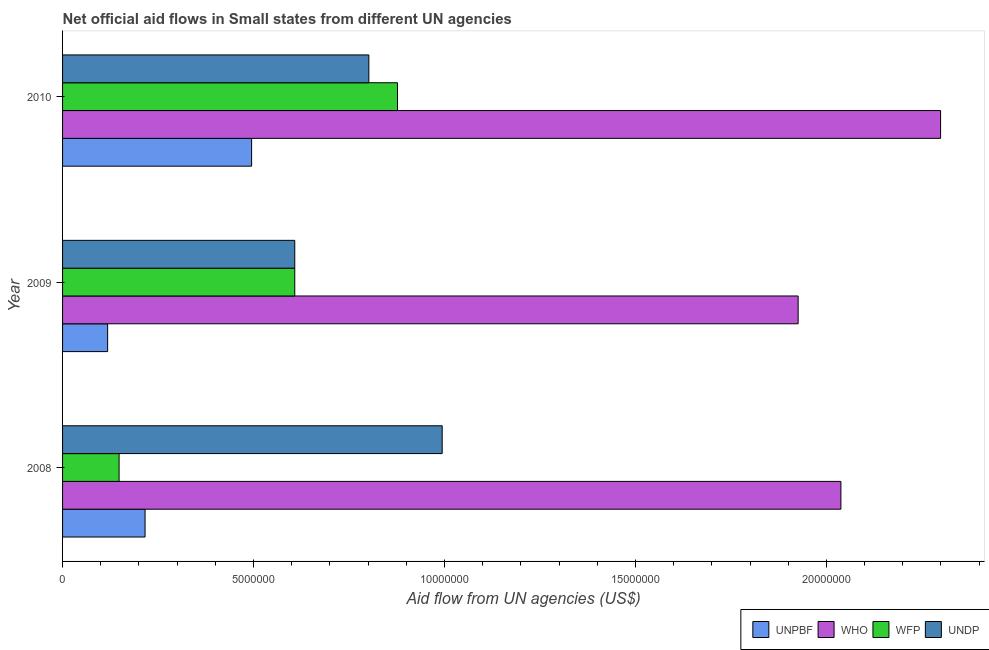How many different coloured bars are there?
Provide a succinct answer. 4. Are the number of bars per tick equal to the number of legend labels?
Your answer should be very brief. Yes. How many bars are there on the 1st tick from the bottom?
Ensure brevity in your answer.  4. What is the label of the 3rd group of bars from the top?
Provide a short and direct response. 2008. What is the amount of aid given by who in 2010?
Your answer should be very brief. 2.30e+07. Across all years, what is the maximum amount of aid given by wfp?
Your answer should be very brief. 8.77e+06. Across all years, what is the minimum amount of aid given by wfp?
Your answer should be very brief. 1.48e+06. In which year was the amount of aid given by wfp minimum?
Offer a terse response. 2008. What is the total amount of aid given by who in the graph?
Provide a succinct answer. 6.26e+07. What is the difference between the amount of aid given by undp in 2008 and that in 2010?
Offer a very short reply. 1.92e+06. What is the difference between the amount of aid given by unpbf in 2009 and the amount of aid given by wfp in 2008?
Provide a short and direct response. -3.00e+05. What is the average amount of aid given by who per year?
Keep it short and to the point. 2.09e+07. In the year 2010, what is the difference between the amount of aid given by wfp and amount of aid given by undp?
Make the answer very short. 7.50e+05. In how many years, is the amount of aid given by unpbf greater than 12000000 US$?
Your answer should be compact. 0. What is the ratio of the amount of aid given by unpbf in 2008 to that in 2010?
Provide a succinct answer. 0.44. Is the amount of aid given by unpbf in 2008 less than that in 2010?
Offer a very short reply. Yes. What is the difference between the highest and the second highest amount of aid given by wfp?
Ensure brevity in your answer.  2.69e+06. What is the difference between the highest and the lowest amount of aid given by undp?
Your response must be concise. 3.86e+06. In how many years, is the amount of aid given by unpbf greater than the average amount of aid given by unpbf taken over all years?
Offer a very short reply. 1. Is the sum of the amount of aid given by undp in 2008 and 2010 greater than the maximum amount of aid given by wfp across all years?
Offer a very short reply. Yes. Is it the case that in every year, the sum of the amount of aid given by unpbf and amount of aid given by wfp is greater than the sum of amount of aid given by who and amount of aid given by undp?
Offer a terse response. Yes. What does the 2nd bar from the top in 2010 represents?
Your response must be concise. WFP. What does the 3rd bar from the bottom in 2010 represents?
Your response must be concise. WFP. Is it the case that in every year, the sum of the amount of aid given by unpbf and amount of aid given by who is greater than the amount of aid given by wfp?
Offer a terse response. Yes. Are all the bars in the graph horizontal?
Your response must be concise. Yes. How many years are there in the graph?
Ensure brevity in your answer.  3. Does the graph contain any zero values?
Provide a short and direct response. No. Does the graph contain grids?
Ensure brevity in your answer.  No. Where does the legend appear in the graph?
Provide a succinct answer. Bottom right. How many legend labels are there?
Provide a succinct answer. 4. What is the title of the graph?
Offer a very short reply. Net official aid flows in Small states from different UN agencies. What is the label or title of the X-axis?
Provide a succinct answer. Aid flow from UN agencies (US$). What is the Aid flow from UN agencies (US$) in UNPBF in 2008?
Make the answer very short. 2.16e+06. What is the Aid flow from UN agencies (US$) of WHO in 2008?
Provide a succinct answer. 2.04e+07. What is the Aid flow from UN agencies (US$) in WFP in 2008?
Your response must be concise. 1.48e+06. What is the Aid flow from UN agencies (US$) in UNDP in 2008?
Give a very brief answer. 9.94e+06. What is the Aid flow from UN agencies (US$) of UNPBF in 2009?
Offer a terse response. 1.18e+06. What is the Aid flow from UN agencies (US$) of WHO in 2009?
Keep it short and to the point. 1.93e+07. What is the Aid flow from UN agencies (US$) in WFP in 2009?
Your answer should be compact. 6.08e+06. What is the Aid flow from UN agencies (US$) of UNDP in 2009?
Give a very brief answer. 6.08e+06. What is the Aid flow from UN agencies (US$) in UNPBF in 2010?
Make the answer very short. 4.95e+06. What is the Aid flow from UN agencies (US$) of WHO in 2010?
Your answer should be compact. 2.30e+07. What is the Aid flow from UN agencies (US$) in WFP in 2010?
Make the answer very short. 8.77e+06. What is the Aid flow from UN agencies (US$) in UNDP in 2010?
Your answer should be compact. 8.02e+06. Across all years, what is the maximum Aid flow from UN agencies (US$) in UNPBF?
Keep it short and to the point. 4.95e+06. Across all years, what is the maximum Aid flow from UN agencies (US$) of WHO?
Offer a terse response. 2.30e+07. Across all years, what is the maximum Aid flow from UN agencies (US$) of WFP?
Make the answer very short. 8.77e+06. Across all years, what is the maximum Aid flow from UN agencies (US$) of UNDP?
Offer a very short reply. 9.94e+06. Across all years, what is the minimum Aid flow from UN agencies (US$) in UNPBF?
Make the answer very short. 1.18e+06. Across all years, what is the minimum Aid flow from UN agencies (US$) of WHO?
Ensure brevity in your answer.  1.93e+07. Across all years, what is the minimum Aid flow from UN agencies (US$) in WFP?
Ensure brevity in your answer.  1.48e+06. Across all years, what is the minimum Aid flow from UN agencies (US$) in UNDP?
Provide a succinct answer. 6.08e+06. What is the total Aid flow from UN agencies (US$) in UNPBF in the graph?
Give a very brief answer. 8.29e+06. What is the total Aid flow from UN agencies (US$) of WHO in the graph?
Your answer should be very brief. 6.26e+07. What is the total Aid flow from UN agencies (US$) in WFP in the graph?
Your response must be concise. 1.63e+07. What is the total Aid flow from UN agencies (US$) of UNDP in the graph?
Provide a short and direct response. 2.40e+07. What is the difference between the Aid flow from UN agencies (US$) in UNPBF in 2008 and that in 2009?
Your answer should be very brief. 9.80e+05. What is the difference between the Aid flow from UN agencies (US$) of WHO in 2008 and that in 2009?
Your answer should be compact. 1.12e+06. What is the difference between the Aid flow from UN agencies (US$) in WFP in 2008 and that in 2009?
Make the answer very short. -4.60e+06. What is the difference between the Aid flow from UN agencies (US$) in UNDP in 2008 and that in 2009?
Provide a short and direct response. 3.86e+06. What is the difference between the Aid flow from UN agencies (US$) of UNPBF in 2008 and that in 2010?
Give a very brief answer. -2.79e+06. What is the difference between the Aid flow from UN agencies (US$) in WHO in 2008 and that in 2010?
Ensure brevity in your answer.  -2.61e+06. What is the difference between the Aid flow from UN agencies (US$) in WFP in 2008 and that in 2010?
Provide a succinct answer. -7.29e+06. What is the difference between the Aid flow from UN agencies (US$) of UNDP in 2008 and that in 2010?
Make the answer very short. 1.92e+06. What is the difference between the Aid flow from UN agencies (US$) of UNPBF in 2009 and that in 2010?
Your response must be concise. -3.77e+06. What is the difference between the Aid flow from UN agencies (US$) of WHO in 2009 and that in 2010?
Provide a short and direct response. -3.73e+06. What is the difference between the Aid flow from UN agencies (US$) in WFP in 2009 and that in 2010?
Keep it short and to the point. -2.69e+06. What is the difference between the Aid flow from UN agencies (US$) of UNDP in 2009 and that in 2010?
Offer a very short reply. -1.94e+06. What is the difference between the Aid flow from UN agencies (US$) in UNPBF in 2008 and the Aid flow from UN agencies (US$) in WHO in 2009?
Ensure brevity in your answer.  -1.71e+07. What is the difference between the Aid flow from UN agencies (US$) of UNPBF in 2008 and the Aid flow from UN agencies (US$) of WFP in 2009?
Offer a terse response. -3.92e+06. What is the difference between the Aid flow from UN agencies (US$) in UNPBF in 2008 and the Aid flow from UN agencies (US$) in UNDP in 2009?
Ensure brevity in your answer.  -3.92e+06. What is the difference between the Aid flow from UN agencies (US$) in WHO in 2008 and the Aid flow from UN agencies (US$) in WFP in 2009?
Offer a very short reply. 1.43e+07. What is the difference between the Aid flow from UN agencies (US$) in WHO in 2008 and the Aid flow from UN agencies (US$) in UNDP in 2009?
Give a very brief answer. 1.43e+07. What is the difference between the Aid flow from UN agencies (US$) in WFP in 2008 and the Aid flow from UN agencies (US$) in UNDP in 2009?
Provide a short and direct response. -4.60e+06. What is the difference between the Aid flow from UN agencies (US$) of UNPBF in 2008 and the Aid flow from UN agencies (US$) of WHO in 2010?
Offer a terse response. -2.08e+07. What is the difference between the Aid flow from UN agencies (US$) of UNPBF in 2008 and the Aid flow from UN agencies (US$) of WFP in 2010?
Keep it short and to the point. -6.61e+06. What is the difference between the Aid flow from UN agencies (US$) of UNPBF in 2008 and the Aid flow from UN agencies (US$) of UNDP in 2010?
Offer a very short reply. -5.86e+06. What is the difference between the Aid flow from UN agencies (US$) of WHO in 2008 and the Aid flow from UN agencies (US$) of WFP in 2010?
Keep it short and to the point. 1.16e+07. What is the difference between the Aid flow from UN agencies (US$) of WHO in 2008 and the Aid flow from UN agencies (US$) of UNDP in 2010?
Offer a very short reply. 1.24e+07. What is the difference between the Aid flow from UN agencies (US$) in WFP in 2008 and the Aid flow from UN agencies (US$) in UNDP in 2010?
Make the answer very short. -6.54e+06. What is the difference between the Aid flow from UN agencies (US$) in UNPBF in 2009 and the Aid flow from UN agencies (US$) in WHO in 2010?
Ensure brevity in your answer.  -2.18e+07. What is the difference between the Aid flow from UN agencies (US$) in UNPBF in 2009 and the Aid flow from UN agencies (US$) in WFP in 2010?
Ensure brevity in your answer.  -7.59e+06. What is the difference between the Aid flow from UN agencies (US$) of UNPBF in 2009 and the Aid flow from UN agencies (US$) of UNDP in 2010?
Make the answer very short. -6.84e+06. What is the difference between the Aid flow from UN agencies (US$) in WHO in 2009 and the Aid flow from UN agencies (US$) in WFP in 2010?
Provide a short and direct response. 1.05e+07. What is the difference between the Aid flow from UN agencies (US$) in WHO in 2009 and the Aid flow from UN agencies (US$) in UNDP in 2010?
Provide a succinct answer. 1.12e+07. What is the difference between the Aid flow from UN agencies (US$) in WFP in 2009 and the Aid flow from UN agencies (US$) in UNDP in 2010?
Give a very brief answer. -1.94e+06. What is the average Aid flow from UN agencies (US$) in UNPBF per year?
Offer a terse response. 2.76e+06. What is the average Aid flow from UN agencies (US$) of WHO per year?
Give a very brief answer. 2.09e+07. What is the average Aid flow from UN agencies (US$) in WFP per year?
Your answer should be very brief. 5.44e+06. What is the average Aid flow from UN agencies (US$) in UNDP per year?
Give a very brief answer. 8.01e+06. In the year 2008, what is the difference between the Aid flow from UN agencies (US$) of UNPBF and Aid flow from UN agencies (US$) of WHO?
Offer a very short reply. -1.82e+07. In the year 2008, what is the difference between the Aid flow from UN agencies (US$) of UNPBF and Aid flow from UN agencies (US$) of WFP?
Your response must be concise. 6.80e+05. In the year 2008, what is the difference between the Aid flow from UN agencies (US$) of UNPBF and Aid flow from UN agencies (US$) of UNDP?
Provide a short and direct response. -7.78e+06. In the year 2008, what is the difference between the Aid flow from UN agencies (US$) of WHO and Aid flow from UN agencies (US$) of WFP?
Your answer should be very brief. 1.89e+07. In the year 2008, what is the difference between the Aid flow from UN agencies (US$) in WHO and Aid flow from UN agencies (US$) in UNDP?
Your answer should be very brief. 1.04e+07. In the year 2008, what is the difference between the Aid flow from UN agencies (US$) in WFP and Aid flow from UN agencies (US$) in UNDP?
Keep it short and to the point. -8.46e+06. In the year 2009, what is the difference between the Aid flow from UN agencies (US$) of UNPBF and Aid flow from UN agencies (US$) of WHO?
Make the answer very short. -1.81e+07. In the year 2009, what is the difference between the Aid flow from UN agencies (US$) of UNPBF and Aid flow from UN agencies (US$) of WFP?
Keep it short and to the point. -4.90e+06. In the year 2009, what is the difference between the Aid flow from UN agencies (US$) of UNPBF and Aid flow from UN agencies (US$) of UNDP?
Give a very brief answer. -4.90e+06. In the year 2009, what is the difference between the Aid flow from UN agencies (US$) in WHO and Aid flow from UN agencies (US$) in WFP?
Your response must be concise. 1.32e+07. In the year 2009, what is the difference between the Aid flow from UN agencies (US$) of WHO and Aid flow from UN agencies (US$) of UNDP?
Give a very brief answer. 1.32e+07. In the year 2010, what is the difference between the Aid flow from UN agencies (US$) in UNPBF and Aid flow from UN agencies (US$) in WHO?
Offer a very short reply. -1.80e+07. In the year 2010, what is the difference between the Aid flow from UN agencies (US$) of UNPBF and Aid flow from UN agencies (US$) of WFP?
Offer a very short reply. -3.82e+06. In the year 2010, what is the difference between the Aid flow from UN agencies (US$) of UNPBF and Aid flow from UN agencies (US$) of UNDP?
Provide a short and direct response. -3.07e+06. In the year 2010, what is the difference between the Aid flow from UN agencies (US$) of WHO and Aid flow from UN agencies (US$) of WFP?
Offer a very short reply. 1.42e+07. In the year 2010, what is the difference between the Aid flow from UN agencies (US$) of WHO and Aid flow from UN agencies (US$) of UNDP?
Your response must be concise. 1.50e+07. In the year 2010, what is the difference between the Aid flow from UN agencies (US$) of WFP and Aid flow from UN agencies (US$) of UNDP?
Offer a terse response. 7.50e+05. What is the ratio of the Aid flow from UN agencies (US$) of UNPBF in 2008 to that in 2009?
Offer a terse response. 1.83. What is the ratio of the Aid flow from UN agencies (US$) in WHO in 2008 to that in 2009?
Keep it short and to the point. 1.06. What is the ratio of the Aid flow from UN agencies (US$) in WFP in 2008 to that in 2009?
Give a very brief answer. 0.24. What is the ratio of the Aid flow from UN agencies (US$) of UNDP in 2008 to that in 2009?
Make the answer very short. 1.63. What is the ratio of the Aid flow from UN agencies (US$) of UNPBF in 2008 to that in 2010?
Your answer should be compact. 0.44. What is the ratio of the Aid flow from UN agencies (US$) in WHO in 2008 to that in 2010?
Your response must be concise. 0.89. What is the ratio of the Aid flow from UN agencies (US$) in WFP in 2008 to that in 2010?
Offer a very short reply. 0.17. What is the ratio of the Aid flow from UN agencies (US$) of UNDP in 2008 to that in 2010?
Your response must be concise. 1.24. What is the ratio of the Aid flow from UN agencies (US$) of UNPBF in 2009 to that in 2010?
Your answer should be compact. 0.24. What is the ratio of the Aid flow from UN agencies (US$) in WHO in 2009 to that in 2010?
Give a very brief answer. 0.84. What is the ratio of the Aid flow from UN agencies (US$) of WFP in 2009 to that in 2010?
Offer a terse response. 0.69. What is the ratio of the Aid flow from UN agencies (US$) of UNDP in 2009 to that in 2010?
Offer a very short reply. 0.76. What is the difference between the highest and the second highest Aid flow from UN agencies (US$) of UNPBF?
Your answer should be compact. 2.79e+06. What is the difference between the highest and the second highest Aid flow from UN agencies (US$) in WHO?
Your answer should be very brief. 2.61e+06. What is the difference between the highest and the second highest Aid flow from UN agencies (US$) in WFP?
Ensure brevity in your answer.  2.69e+06. What is the difference between the highest and the second highest Aid flow from UN agencies (US$) in UNDP?
Keep it short and to the point. 1.92e+06. What is the difference between the highest and the lowest Aid flow from UN agencies (US$) in UNPBF?
Provide a short and direct response. 3.77e+06. What is the difference between the highest and the lowest Aid flow from UN agencies (US$) of WHO?
Provide a succinct answer. 3.73e+06. What is the difference between the highest and the lowest Aid flow from UN agencies (US$) in WFP?
Your answer should be compact. 7.29e+06. What is the difference between the highest and the lowest Aid flow from UN agencies (US$) of UNDP?
Offer a terse response. 3.86e+06. 